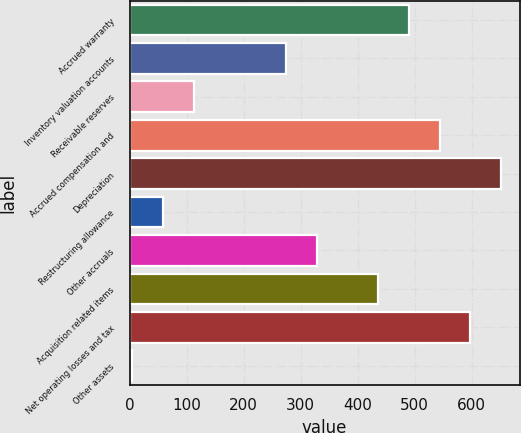Convert chart to OTSL. <chart><loc_0><loc_0><loc_500><loc_500><bar_chart><fcel>Accrued warranty<fcel>Inventory valuation accounts<fcel>Receivable reserves<fcel>Accrued compensation and<fcel>Depreciation<fcel>Restructuring allowance<fcel>Other accruals<fcel>Acquisition related items<fcel>Net operating losses and tax<fcel>Other assets<nl><fcel>490.1<fcel>274.5<fcel>112.8<fcel>544<fcel>651.8<fcel>58.9<fcel>328.4<fcel>436.2<fcel>597.9<fcel>5<nl></chart> 